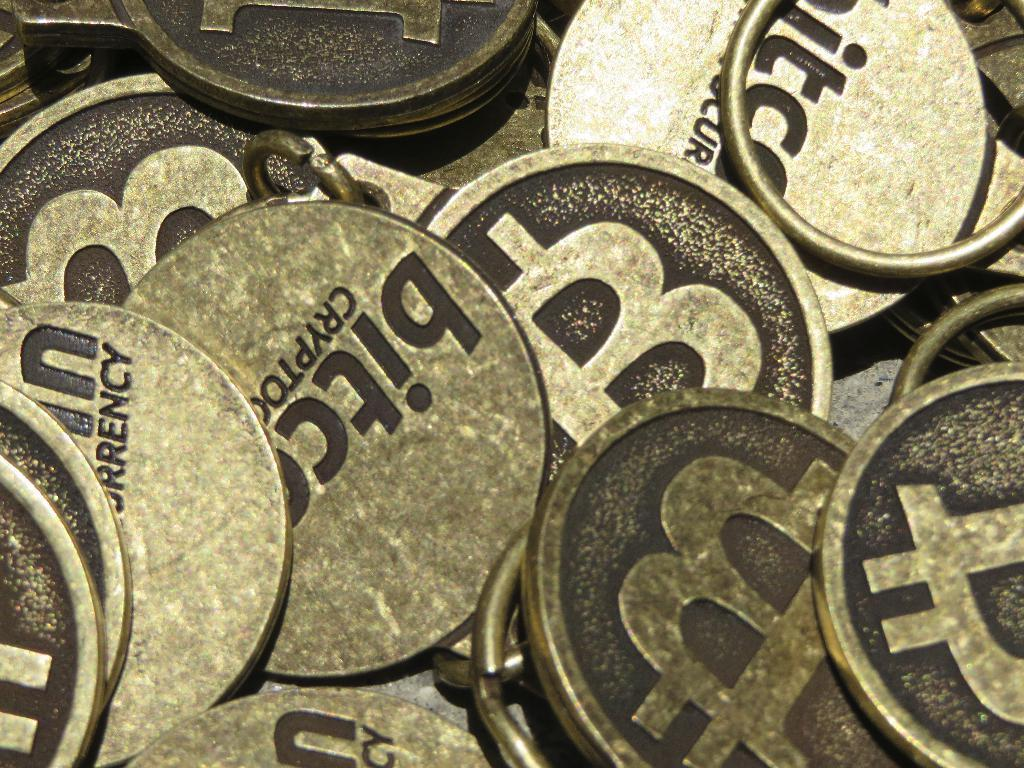What objects are present in the image? There are coins in the image. What can be found on the surface of the coins? There is text on the coins. How many chickens are standing on the wrist in the image? There are no chickens or wrists present in the image; it only features coins with text on them. 